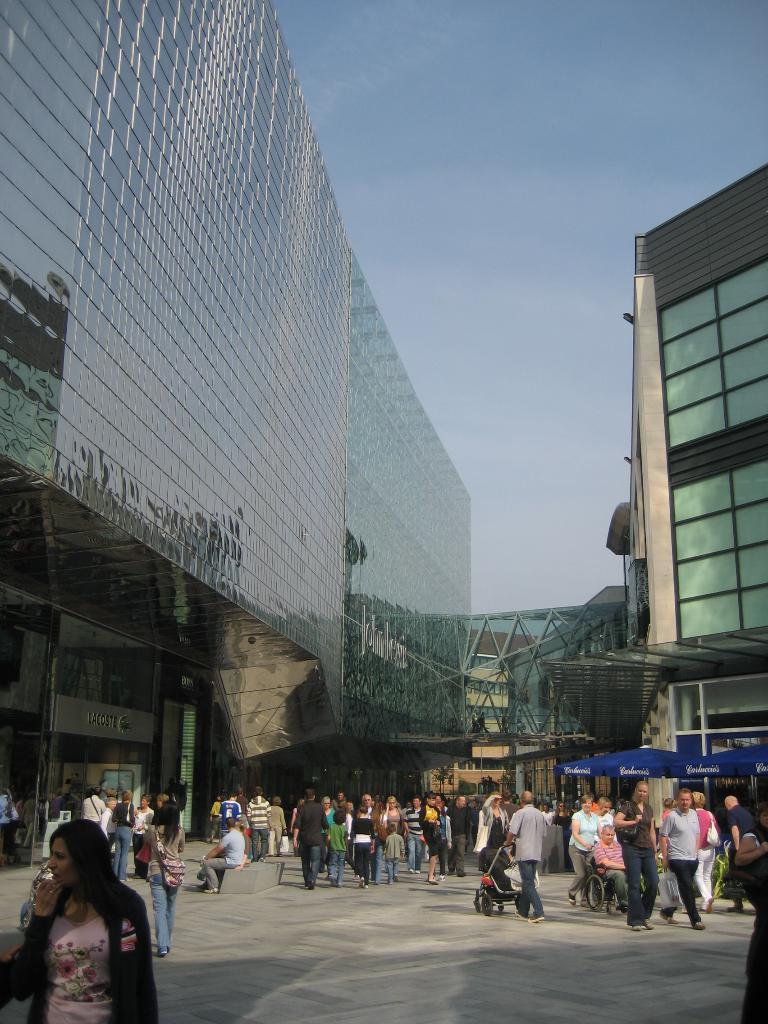What are the people in the center of the image doing? The people are standing in the center of the image and holding objects. What can be seen in the background of the image? There is a sky, clouds, buildings, and banners visible in the background of the image. What might the objects held by the people be used for? The objects held by the people could be used for various purposes, but without more information, it is difficult to determine their specific use. What is the size of the zephyr in the image? There is no zephyr present in the image; a zephyr refers to a gentle breeze, which cannot be seen in a photograph. 